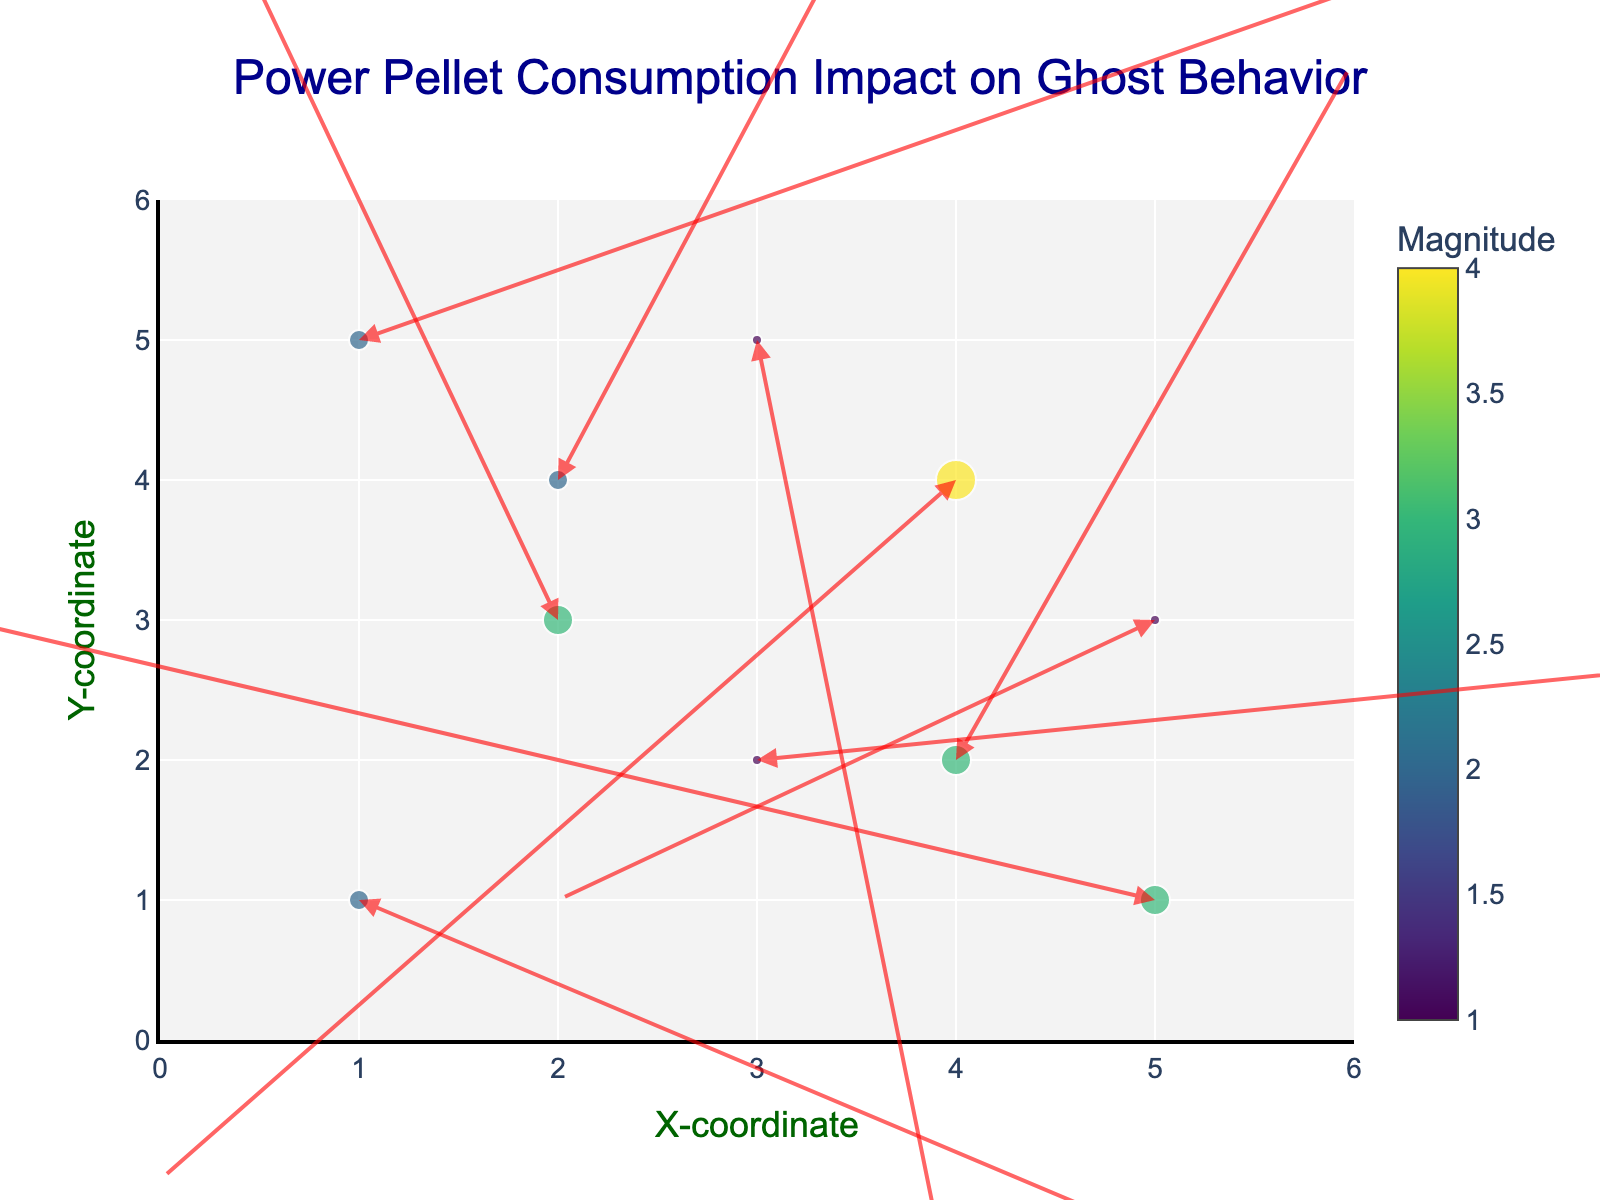What is the title of the figure? The title is typically shown at the top of the figure and helps to understand the main topic or focus of the plot. In this quiver plot, the title is clearly indicated.
Answer: Power Pellet Consumption Impact on Ghost Behavior What are the axes labels on the plot? Axes labels are present to indicate what the x and y coordinates represent in the plot. This information is crucial to interpret the data points correctly.
Answer: X-coordinate and Y-coordinate How is the magnitude of each data point represented visually? Magnitude in scatter plots can be depicted by different attributes like color intensity, size of data points, etc. In this plot, the size and color of the markers reflect the magnitude, where larger sizes and color intensity indicate higher magnitudes.
Answer: By the size and color of the markers Which data point has the highest magnitude? To determine the highest magnitude, one must look for the largest and most richly colored marker in the plot.
Answer: The data point at (4,4) What is the general trend in the direction of the arrows? By observing the arrows' directions (u,v vectors), one should note the predominant trends, such as the general movement direction of ghosts after power pellet consumption.
Answer: The arrows are pointing in various directions, indicating no single uniform trend How many data points are there in the plot? Counting the number of markers (points) on the scatter plot reveals the number of data points represented in the plot.
Answer: 10 What is the average magnitude of the data points? Sum the magnitudes of all the data points and then divide by the number of data points to find the average. The magnitudes are: 2, 3, 1, 4, 2, 3, 1, 2, 1, 3. Sum = 22, Number of points = 10, thus average = 22/10
Answer: 2.2 Which direction does the arrow at point (2, 3) point toward? The quiver plot uses arrows to indicate direction (u, v vectors). For the point (2,3), it needs checking the vector direction, where (u, v) = (-0.2, 0.6). The arrow should point approximately towards the top-left but more upward.
Answer: Upward and slightly to the left Compare the magnitudes of the arrows at (1,1) and (2,3). Which one is larger? Examining the sizes of data points or checking their magnitude values shows which one indicates a higher value. Point (1,1) has magnitude 2, and point (2,3) has magnitude 3.
Answer: The arrow at (2,3) has a larger magnitude 